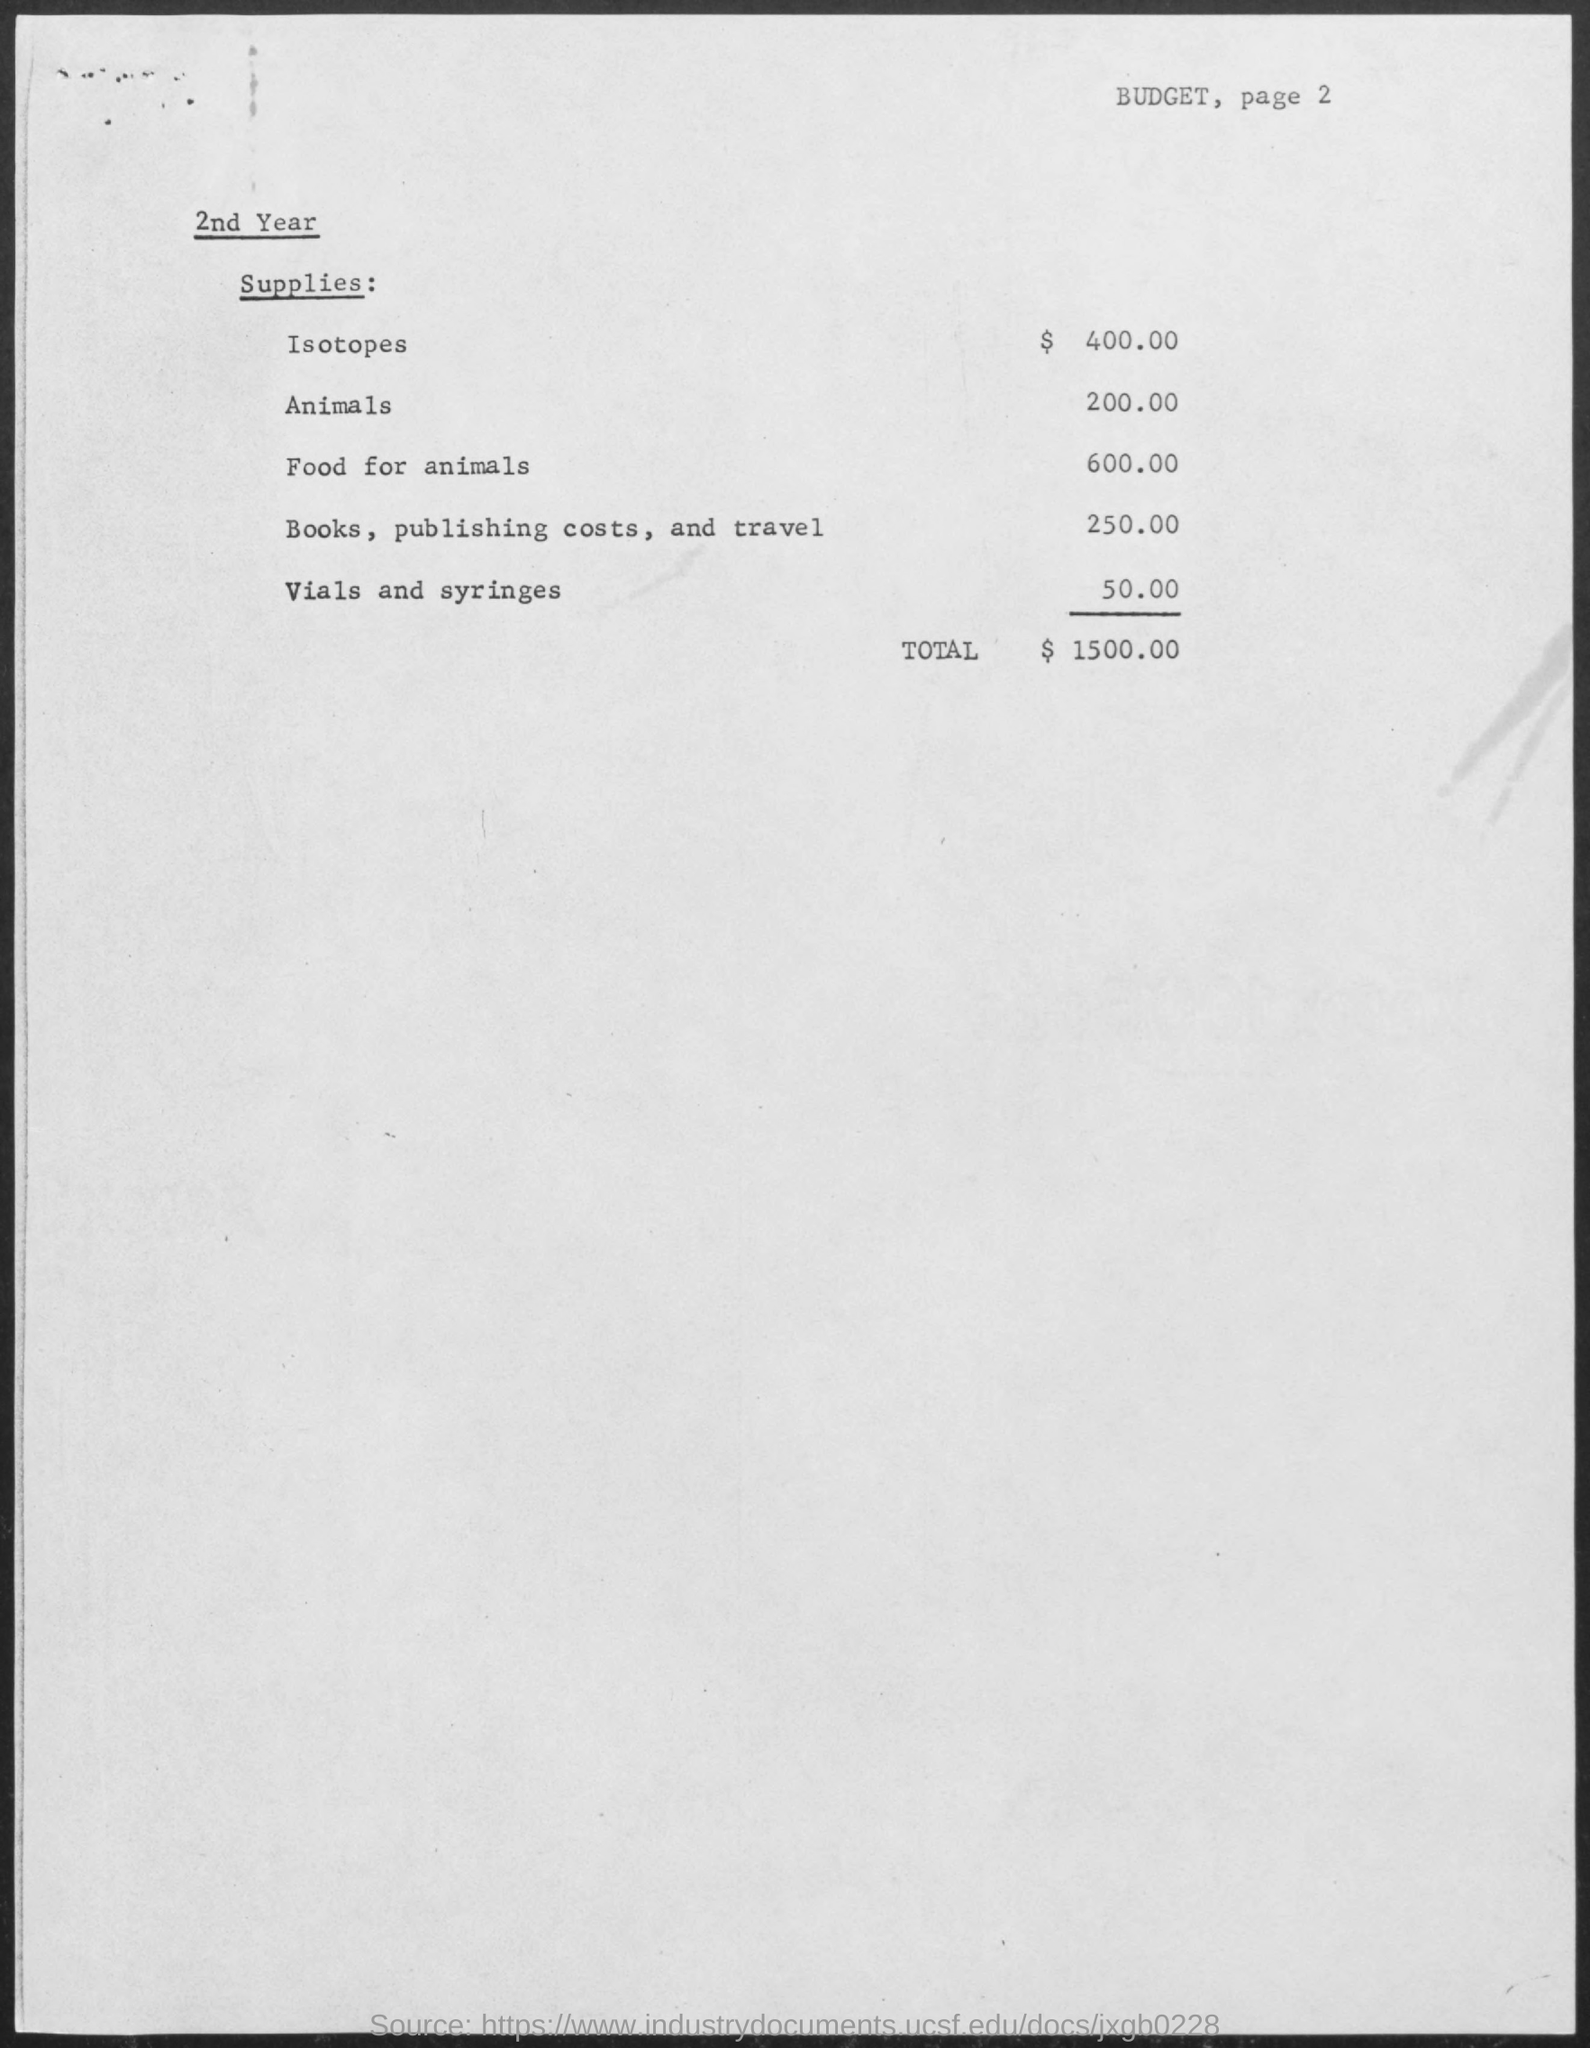Outline some significant characteristics in this image. The budget allocated for animals is 200.00. The total budget mentioned is 1500.00. The budget for vials and syringes is 50.00. The budget for isotopes is 400.00. The budget for food for animals is 600.00. 